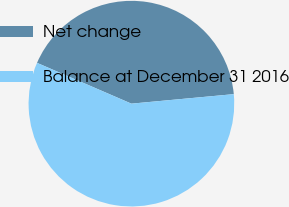<chart> <loc_0><loc_0><loc_500><loc_500><pie_chart><fcel>Net change<fcel>Balance at December 31 2016<nl><fcel>42.03%<fcel>57.97%<nl></chart> 